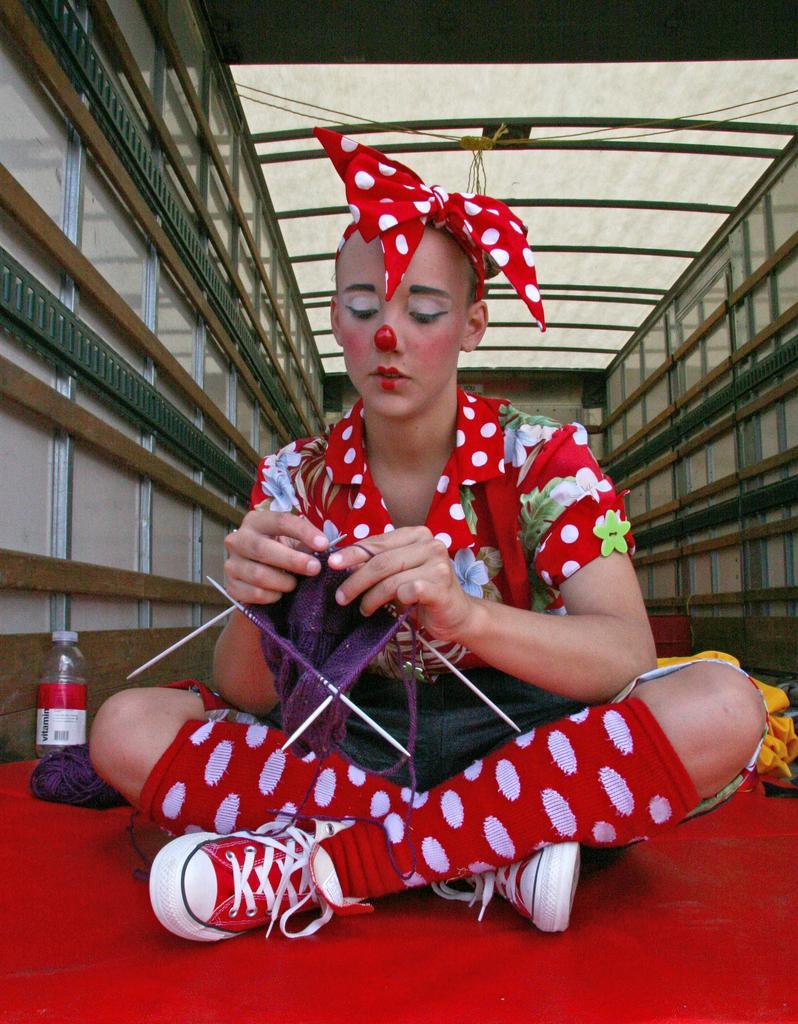Describe this image in one or two sentences. In this image there is a wall with wood and metal design in the left and right corner. There is a bottle in the left corner. There is a person in the foreground. There is a floor at the bottom. And there is a roof at the top. 